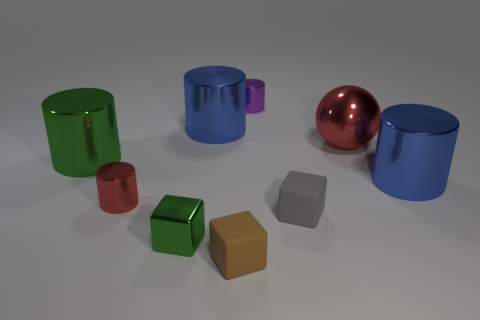Subtract 1 cylinders. How many cylinders are left? 4 Subtract all purple cylinders. How many cylinders are left? 4 Subtract all red cylinders. How many cylinders are left? 4 Subtract all gray cylinders. Subtract all green blocks. How many cylinders are left? 5 Subtract all cylinders. How many objects are left? 4 Add 2 small red cylinders. How many small red cylinders exist? 3 Subtract 0 purple blocks. How many objects are left? 9 Subtract all small brown matte things. Subtract all purple metallic objects. How many objects are left? 7 Add 6 large blue shiny cylinders. How many large blue shiny cylinders are left? 8 